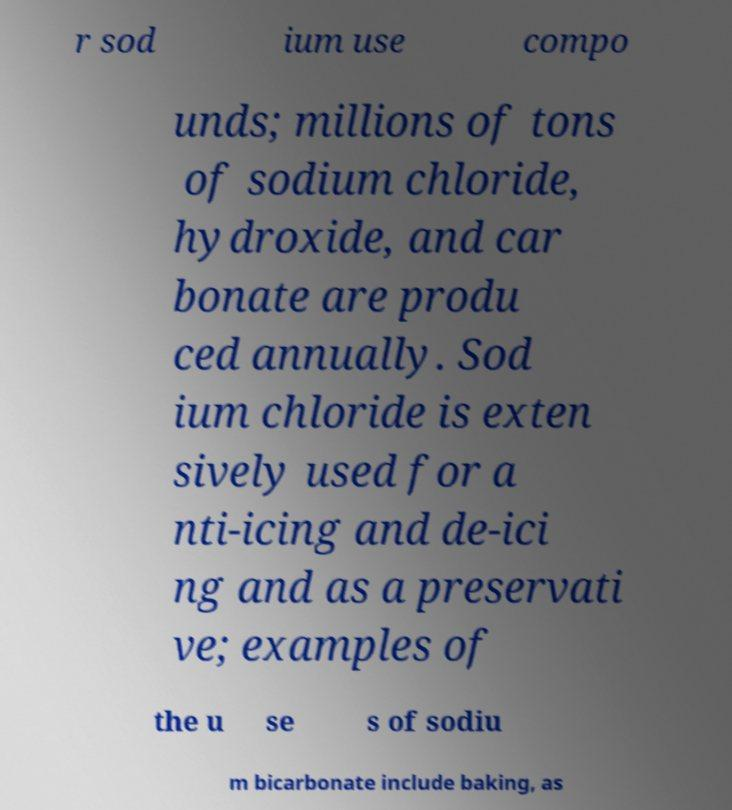There's text embedded in this image that I need extracted. Can you transcribe it verbatim? r sod ium use compo unds; millions of tons of sodium chloride, hydroxide, and car bonate are produ ced annually. Sod ium chloride is exten sively used for a nti-icing and de-ici ng and as a preservati ve; examples of the u se s of sodiu m bicarbonate include baking, as 